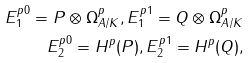Convert formula to latex. <formula><loc_0><loc_0><loc_500><loc_500>E _ { 1 } ^ { p 0 } = P \otimes \Omega ^ { p } _ { A / K } , E _ { 1 } ^ { p 1 } = Q \otimes \Omega ^ { p } _ { A / K } \\ E _ { 2 } ^ { p 0 } = H ^ { p } ( P ) , E _ { 2 } ^ { p 1 } = H ^ { p } ( Q ) ,</formula> 